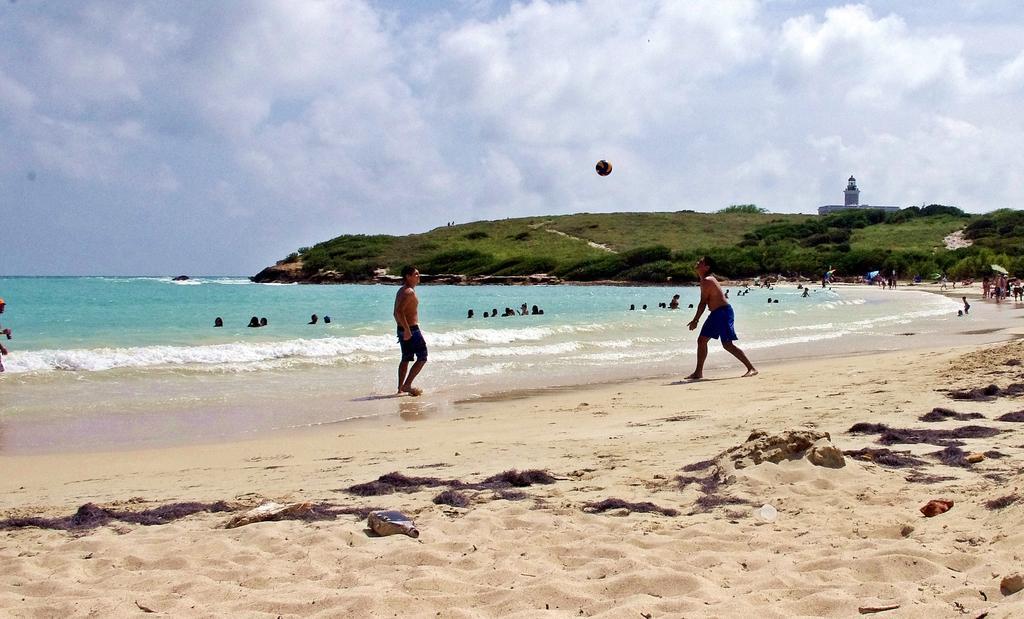How would you summarize this image in a sentence or two? Sky is cloudy. Ball is in the air. Here we can see soil, water and people. Few people are in water. Far there is a building, grass and plants. 